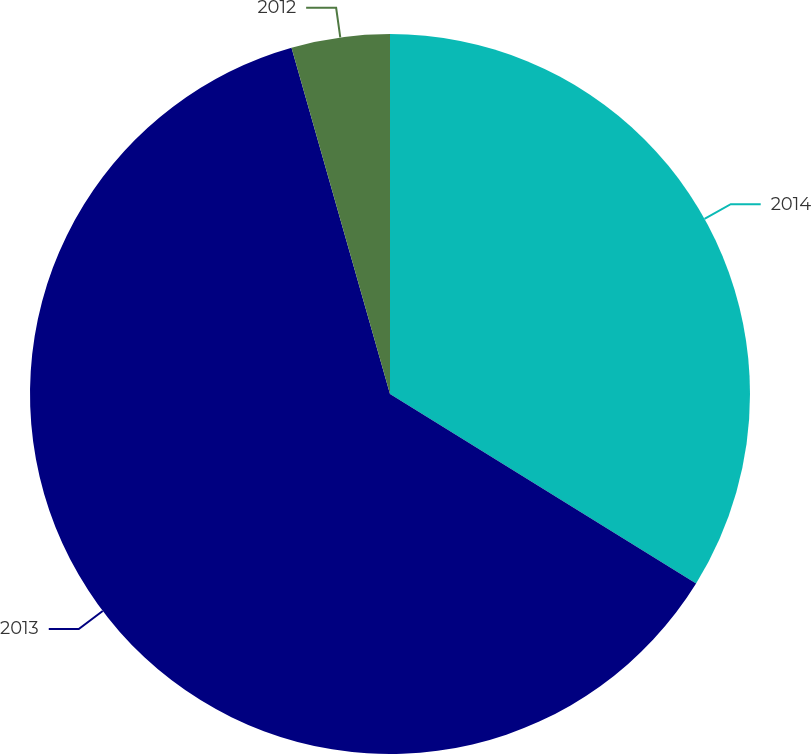<chart> <loc_0><loc_0><loc_500><loc_500><pie_chart><fcel>2014<fcel>2013<fcel>2012<nl><fcel>33.82%<fcel>61.76%<fcel>4.41%<nl></chart> 